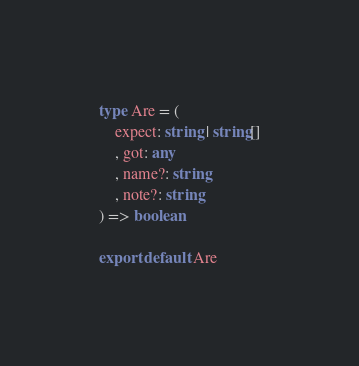<code> <loc_0><loc_0><loc_500><loc_500><_TypeScript_>type Are = (
    expect: string | string[]
    , got: any
    , name?: string
    , note?: string
) => boolean 

export default Are</code> 